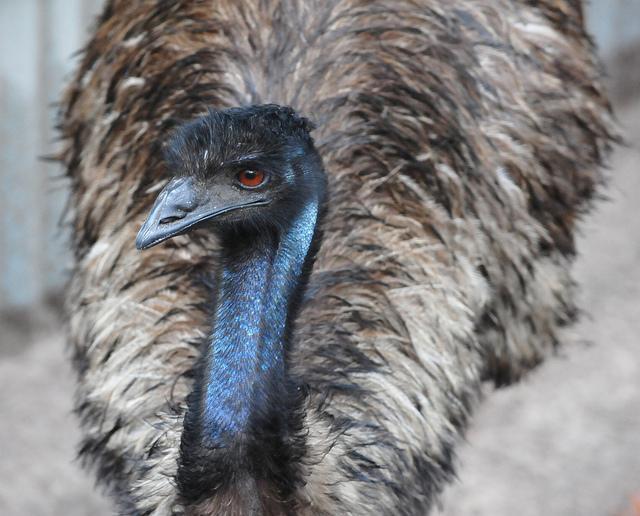How many people are pictured?
Give a very brief answer. 0. 